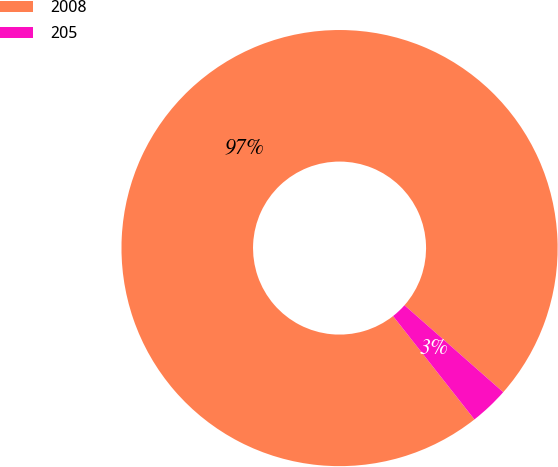Convert chart to OTSL. <chart><loc_0><loc_0><loc_500><loc_500><pie_chart><fcel>2008<fcel>205<nl><fcel>97.1%<fcel>2.9%<nl></chart> 